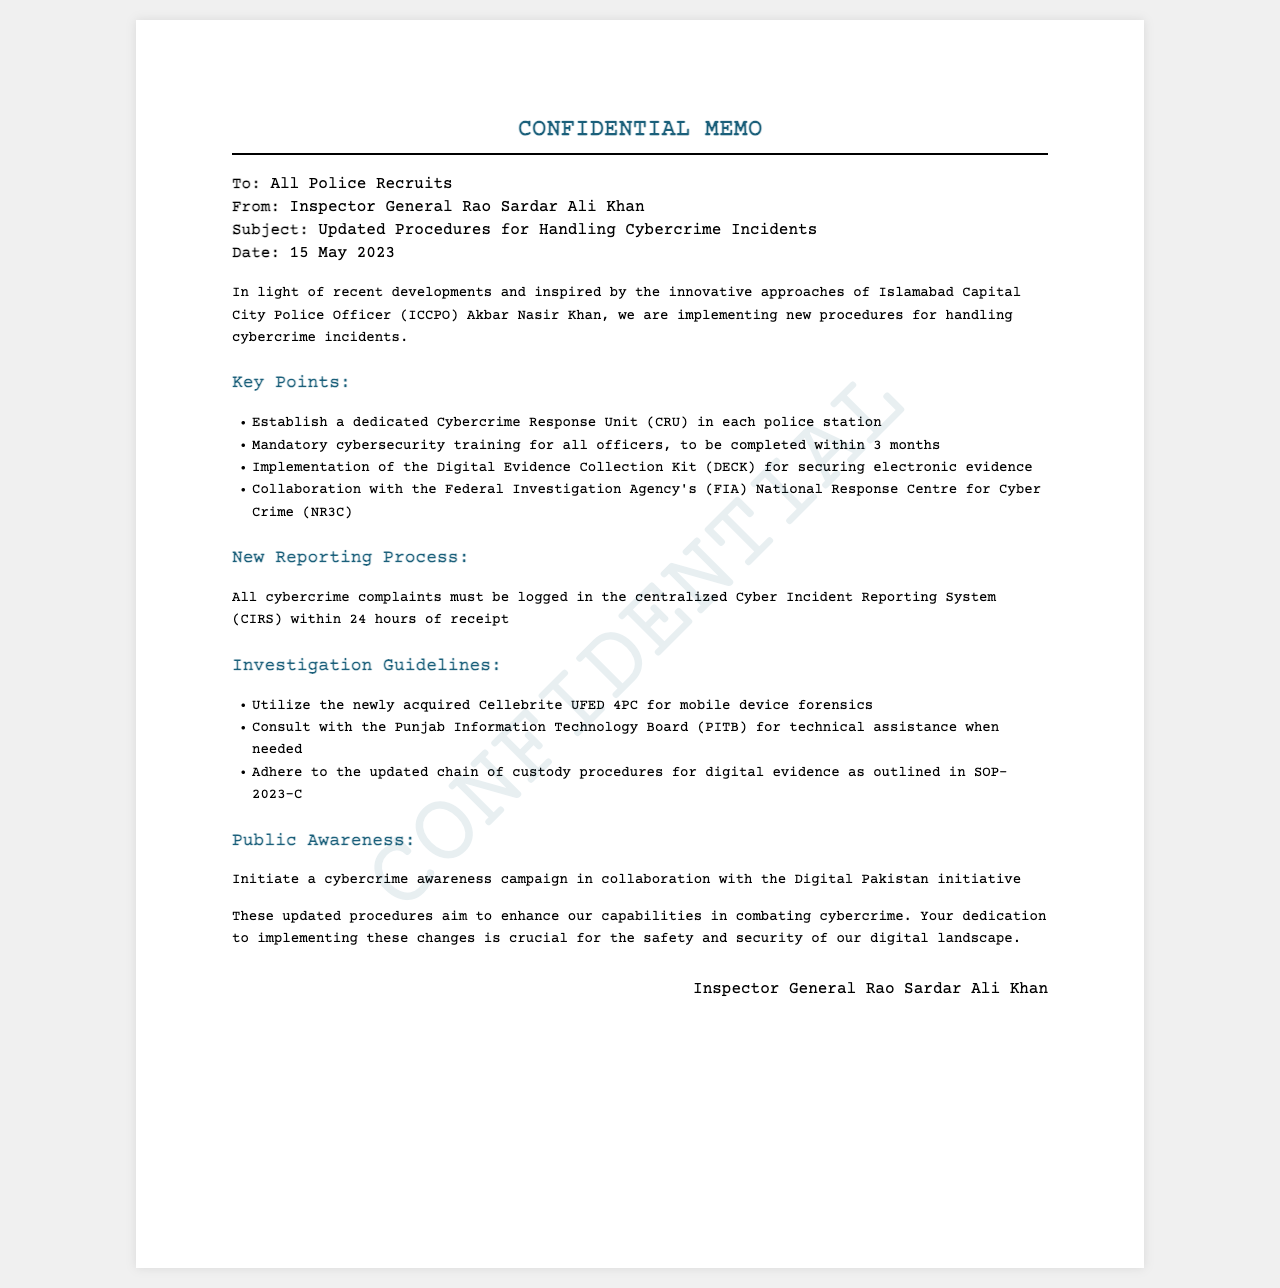What is the title of the memo? The title is indicated at the top of the document as the main heading.
Answer: CONFIDENTIAL MEMO Who is the sender of the memo? The sender is specified in the meta section of the document.
Answer: Inspector General Rao Sardar Ali Khan What is the date of the memo? The date is listed in the meta section, informing recipients when it was issued.
Answer: 15 May 2023 What is the first key point mentioned in the memo? The first key point is listed in the content section under the key points header.
Answer: Establish a dedicated Cybercrime Response Unit (CRU) in each police station What must all cybercrime complaints be logged in? This information is provided in the specific section regarding the new reporting process.
Answer: Cyber Incident Reporting System (CIRS) Which forensic tool will be utilized for mobile device forensics? This is specified under the investigation guidelines section.
Answer: Cellebrite UFED 4PC What is the purpose of the updated procedures mentioned in the memo? The last paragraph summarizes the overall aim of the new updates.
Answer: Enhance our capabilities in combating cybercrime What type of campaign is to be initiated in collaboration with the Digital Pakistan initiative? This information can be found in the public awareness section of the document.
Answer: Cybercrime awareness campaign 